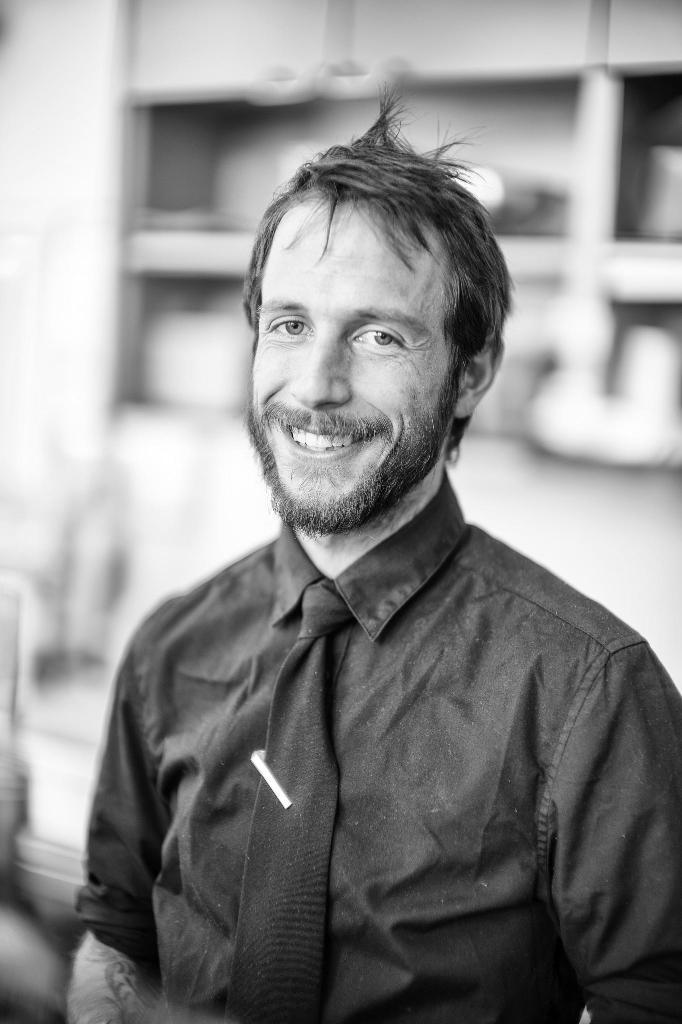Who or what is present in the image? There is a person in the image. What is the person wearing around their neck? The person is wearing a tie. What object is near the tie? There is a pen near the tie. What can be seen behind the person? There are shelves visible behind the person. What type of butter is being used by the person in the image? There is no butter present in the image. 